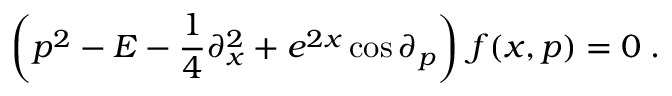<formula> <loc_0><loc_0><loc_500><loc_500>\left ( p ^ { 2 } - E - { \frac { 1 } { 4 } } \partial _ { x } ^ { 2 } + e ^ { 2 x } \cos \partial _ { p } \right ) \, f ( x , p ) = 0 \, .</formula> 